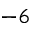Convert formula to latex. <formula><loc_0><loc_0><loc_500><loc_500>^ { - 6 }</formula> 